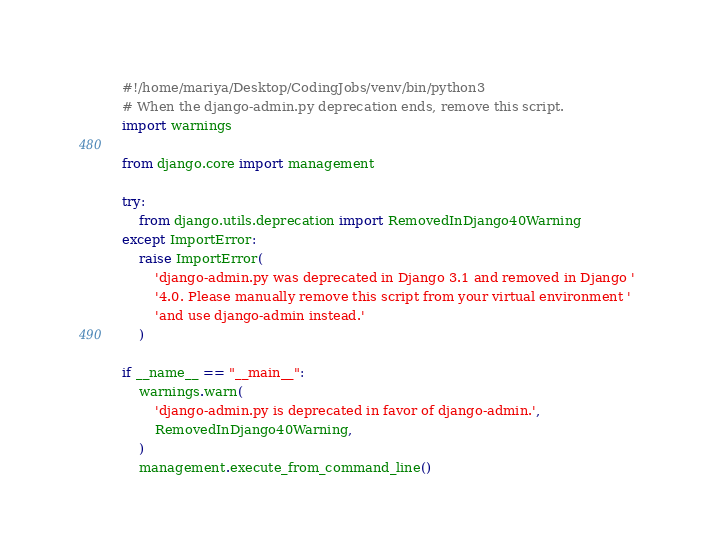<code> <loc_0><loc_0><loc_500><loc_500><_Python_>#!/home/mariya/Desktop/CodingJobs/venv/bin/python3
# When the django-admin.py deprecation ends, remove this script.
import warnings

from django.core import management

try:
    from django.utils.deprecation import RemovedInDjango40Warning
except ImportError:
    raise ImportError(
        'django-admin.py was deprecated in Django 3.1 and removed in Django '
        '4.0. Please manually remove this script from your virtual environment '
        'and use django-admin instead.'
    )

if __name__ == "__main__":
    warnings.warn(
        'django-admin.py is deprecated in favor of django-admin.',
        RemovedInDjango40Warning,
    )
    management.execute_from_command_line()
</code> 